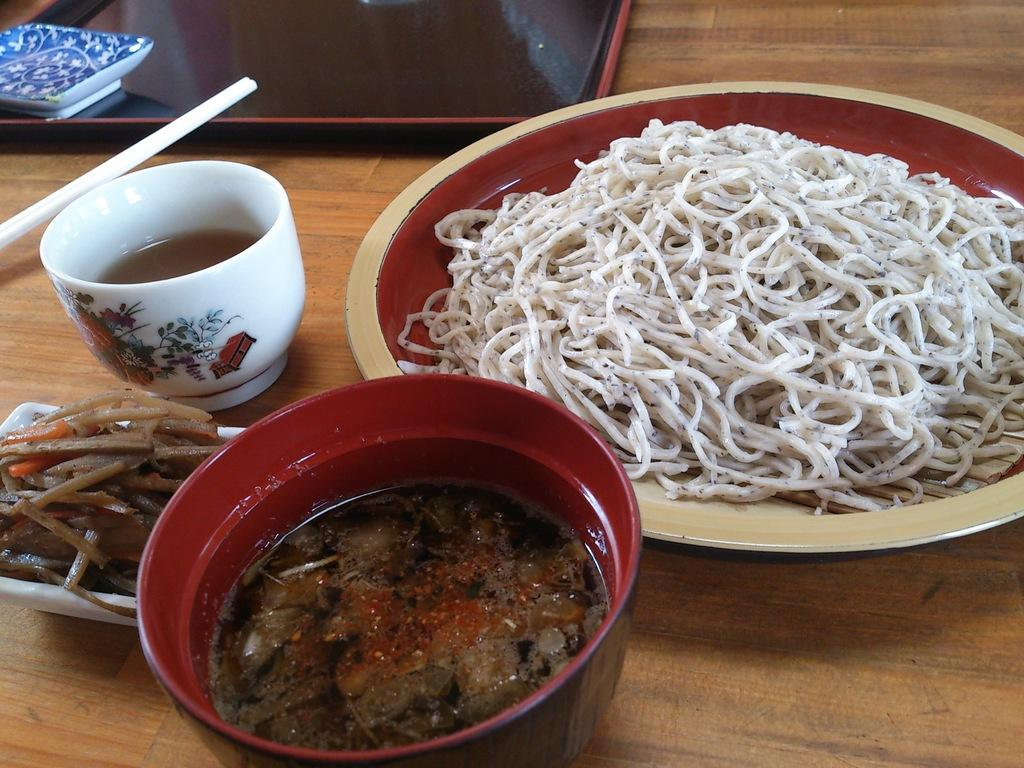What is in the bowl that is visible in the image? There is a bowl with curry in the image. What is on the plate that is visible in the image? There is a plate with noodles in the image. What is in the other bowl that is visible in the image? There is a bowl with soup in the image. What utensils are present on the table in the image? Chopsticks are visible on the table in the image. Where are the rabbits playing in the image? There are no rabbits present in the image. What type of yarn is being used to decorate the park in the image? There is no park or yarn present in the image. 